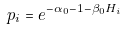Convert formula to latex. <formula><loc_0><loc_0><loc_500><loc_500>p _ { i } = e ^ { - \alpha _ { 0 } - 1 - \beta _ { 0 } H _ { i } }</formula> 